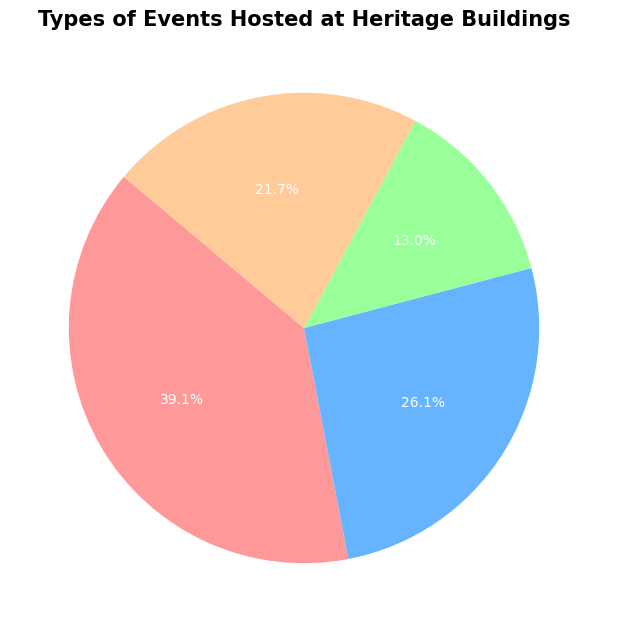what type of event has the highest percentage of the total events? The pie chart shows four categories of events with their percentages. The largest sector represents cultural events, which have the highest percentage at 45 events.
Answer: Cultural How many more cultural events are there compared to private events? To find the difference, subtract the number of private events (15) from the number of cultural events (45). The calculation is 45 - 15 = 30.
Answer: 30 Which category hosts fewer events than public events but more than private events? Private events have 15 events, public events have 25, and educational events have 30. Educational events are the only category between private and public events.
Answer: Educational What percentage of the total events are educational? The pie chart includes the percentage for each type of event. Educational events make up 30 out of the total sum of all events (115). The percentage is therefore (30/115) * 100, which simplifies to about 26.1%.
Answer: 26.1% Are there more public events or educational events, and by how many? Compare the number of public events (25) to educational events (30) to find that there are more educational events. Subtract the smaller number from the larger to find the difference: 30 - 25 = 5.
Answer: Educational, by 5 events What's the combined percentage of cultural and public events? Add the number of cultural events (45) to the number of public events (25) to get a total of 70 events. The combined percentage is (70/115) * 100, which is about 60.9%.
Answer: 60.9% What is the smallest segment in the pie chart, and what percentage does it represent? The smallest segment is the one with the fewest events. Private events have the fewest (15), which represent (15/115) * 100, or 13% of the total.
Answer: Private, 13% Out of the total number of events, how many are not cultural or public? Subtract the number of cultural events (45) and the number of public events (25) from the total number of events (115): 115 - 45 - 25 = 45 events.
Answer: 45 What is the ratio of educational to public events? There are 30 educational events and 25 public events. The ratio is 30:25, which simplifies to 6:5.
Answer: 6:5 